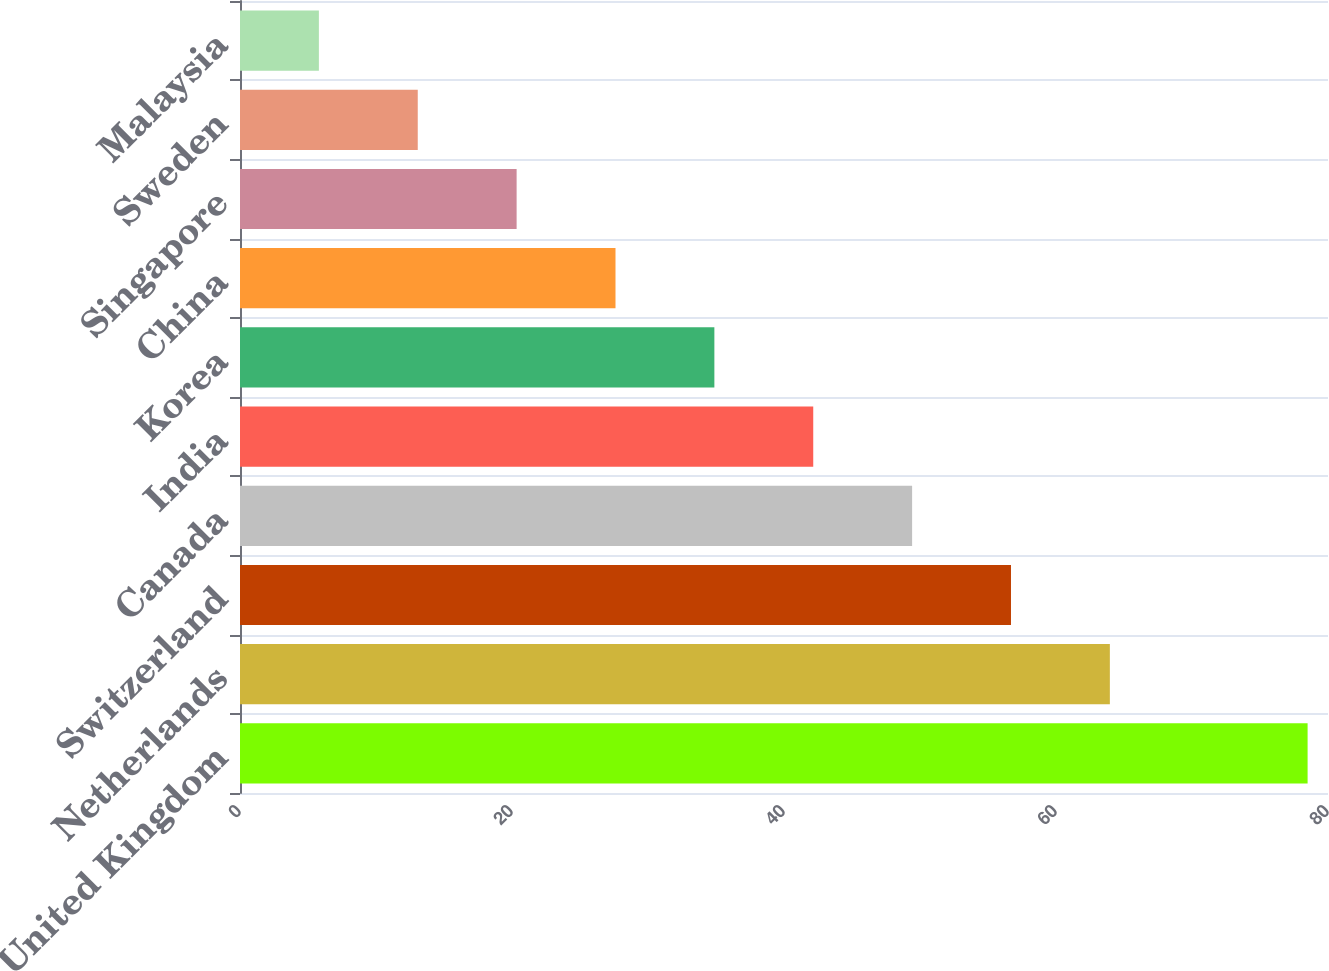Convert chart. <chart><loc_0><loc_0><loc_500><loc_500><bar_chart><fcel>United Kingdom<fcel>Netherlands<fcel>Switzerland<fcel>Canada<fcel>India<fcel>Korea<fcel>China<fcel>Singapore<fcel>Sweden<fcel>Malaysia<nl><fcel>78.5<fcel>63.96<fcel>56.69<fcel>49.42<fcel>42.15<fcel>34.88<fcel>27.61<fcel>20.34<fcel>13.07<fcel>5.8<nl></chart> 